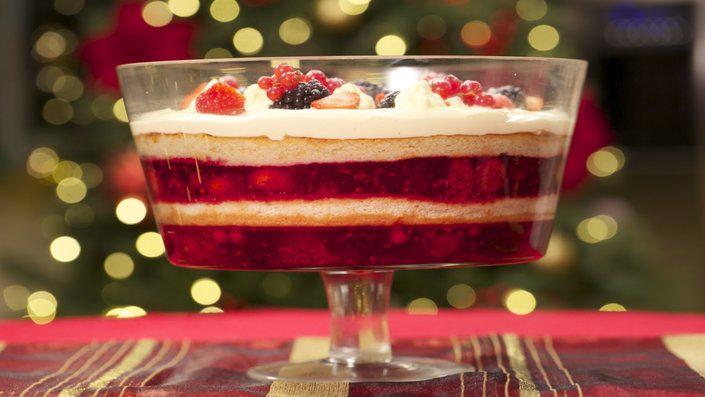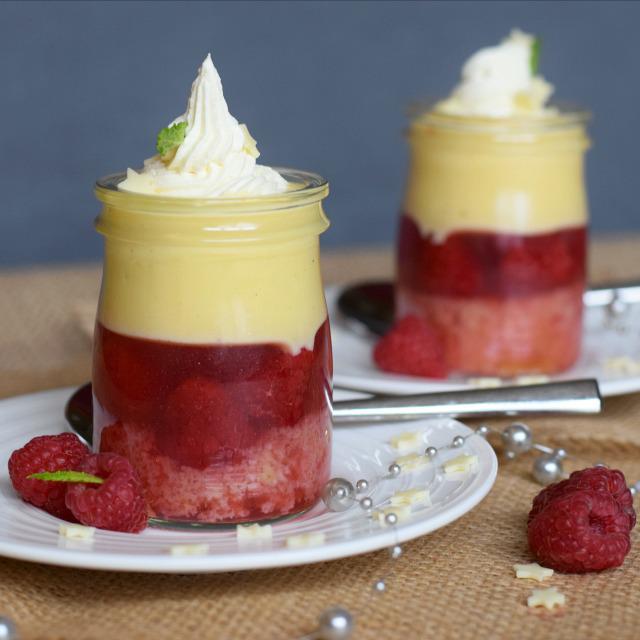The first image is the image on the left, the second image is the image on the right. For the images shown, is this caption "An image shows at least two layered desserts served in clear non-footed glasses and each garnished with a single red berry." true? Answer yes or no. No. 